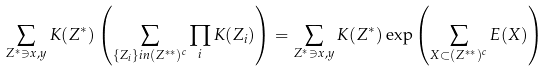<formula> <loc_0><loc_0><loc_500><loc_500>\sum _ { Z ^ { * } \ni x , y } K ( Z ^ { * } ) \left ( \sum _ { \{ Z _ { i } \} i n ( Z ^ { * * } ) ^ { c } } \prod _ { i } K ( Z _ { i } ) \right ) = \sum _ { Z ^ { * } \ni x , y } K ( Z ^ { * } ) \exp \left ( \sum _ { X \subset ( Z ^ { * * } ) ^ { c } } E ( X ) \right )</formula> 